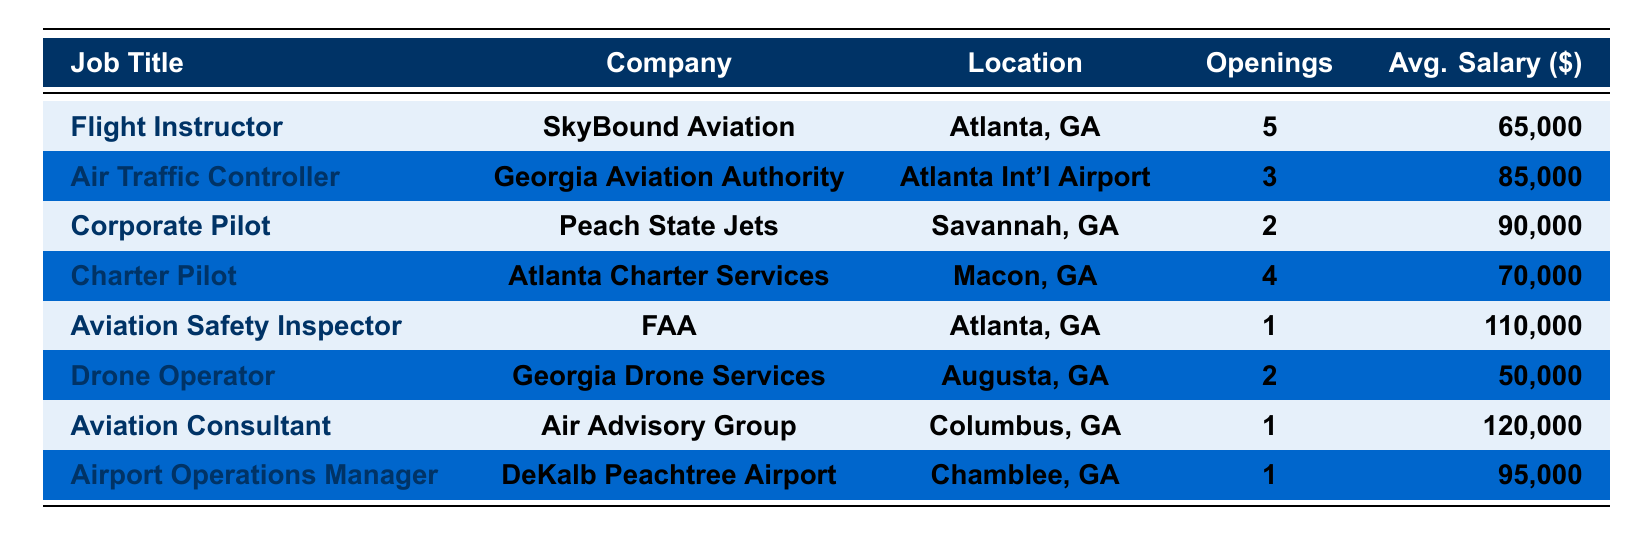What is the highest average salary among the job openings listed? The job titles and their corresponding average salaries are: Flight Instructor ($65,000), Air Traffic Controller ($85,000), Corporate Pilot ($90,000), Charter Pilot ($70,000), Aviation Safety Inspector ($110,000), Drone Operator ($50,000), Aviation Consultant ($120,000), and Airport Operations Manager ($95,000). The highest average salary is $120,000 for the Aviation Consultant position.
Answer: $120,000 How many job openings are available for Flight Instructors? The table indicates there are 5 openings for the Flight Instructor position at SkyBound Aviation in Atlanta, GA.
Answer: 5 Which job has the least number of openings? The Aviation Safety Inspector and Aviation Consultant both have only 1 opening each. Among these, Aviation Safety Inspector has the lowest average salary of $110,000, while the Aviation Consultant, despite being the lowest in openings, has a higher salary of $120,000. Therefore, either could be considered least based on openings.
Answer: Aviation Safety Inspector and Aviation Consultant have least openings What is the total number of job openings for all positions? To find the total sum of job openings, we add: 5 (Flight Instructor) + 3 (Air Traffic Controller) + 2 (Corporate Pilot) + 4 (Charter Pilot) + 1 (Aviation Safety Inspector) + 2 (Drone Operator) + 1 (Aviation Consultant) + 1 (Airport Operations Manager) = 19.
Answer: 19 Which position requires the most aviation experience based on its requirements? The Aviation Safety Inspector requires 10 years of aviation experience, which is more than any other position listed.
Answer: Aviation Safety Inspector Are there more job openings for instructors than for controllers? The table shows 5 openings for Flight Instructors and 3 openings for Air Traffic Controllers. Since 5 is greater than 3, there are indeed more instructor openings than controller openings.
Answer: Yes What is the average salary of the two positions with the least openings? The two positions with the least openings are the Aviation Safety Inspector and Aviation Consultant, each with 1 opening. Their salaries are $110,000 and $120,000 respectively. The average is calculated as ($110,000 + $120,000) / 2 = $115,000.
Answer: $115,000 How many positions are available that require a Commercial Pilot License? The table lists the Flight Instructor, Charter Pilot, and Aviation Safety Inspector positions as requiring a Commercial Pilot License. Therefore, there are 3 positions that require this license.
Answer: 3 